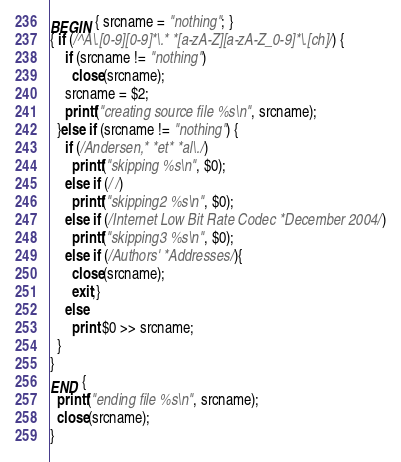Convert code to text. <code><loc_0><loc_0><loc_500><loc_500><_Awk_>BEGIN { srcname = "nothing"; }
{ if (/^A\.[0-9][0-9]*\.* *[a-zA-Z][a-zA-Z_0-9]*\.[ch]/) {
    if (srcname != "nothing")
      close(srcname);
    srcname = $2;
    printf("creating source file %s\n", srcname);
  }else if (srcname != "nothing") {
    if (/Andersen,* *et* *al\./) 
      printf("skipping %s\n", $0);
    else if (//)
      printf("skipping2 %s\n", $0);
    else if (/Internet Low Bit Rate Codec *December 2004/)
      printf("skipping3 %s\n", $0);
    else if (/Authors' *Addresses/){
      close(srcname);
      exit;}
    else
      print $0 >> srcname;
  }
}
END {
  printf("ending file %s\n", srcname);
  close(srcname);
}
</code> 